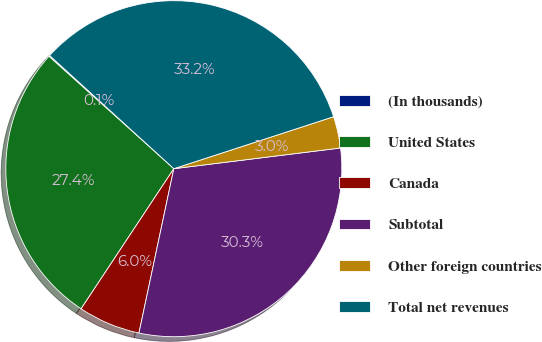Convert chart to OTSL. <chart><loc_0><loc_0><loc_500><loc_500><pie_chart><fcel>(In thousands)<fcel>United States<fcel>Canada<fcel>Subtotal<fcel>Other foreign countries<fcel>Total net revenues<nl><fcel>0.1%<fcel>27.36%<fcel>5.98%<fcel>30.3%<fcel>3.04%<fcel>33.24%<nl></chart> 